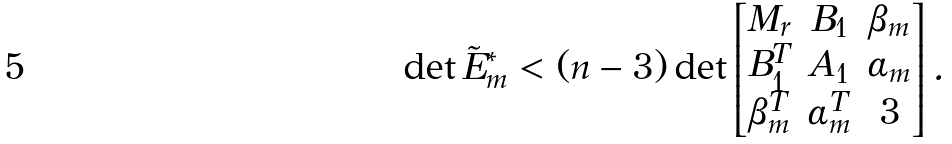<formula> <loc_0><loc_0><loc_500><loc_500>\det \tilde { E } _ { m } ^ { * } < ( n - 3 ) \det \begin{bmatrix} M _ { r } & B _ { 1 } & \beta _ { m } \\ B _ { 1 } ^ { T } & A _ { 1 } & \alpha _ { m } \\ \beta _ { m } ^ { T } & \alpha _ { m } ^ { T } & 3 \end{bmatrix} .</formula> 